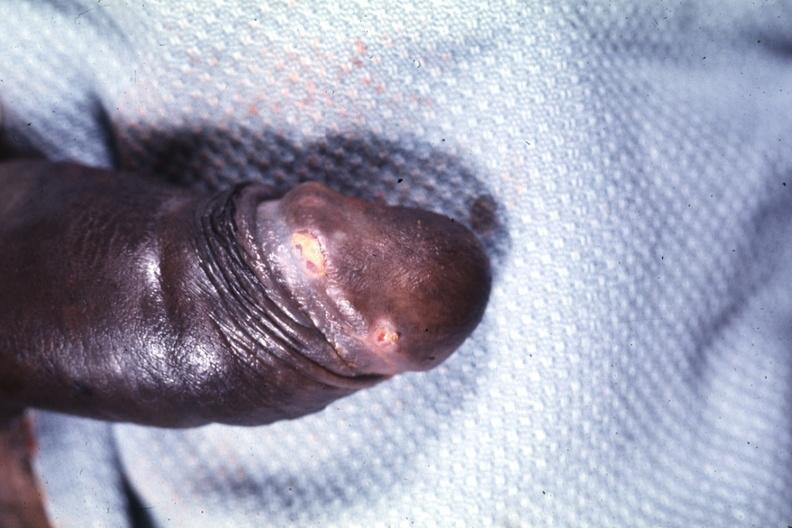what is present?
Answer the question using a single word or phrase. Penis 